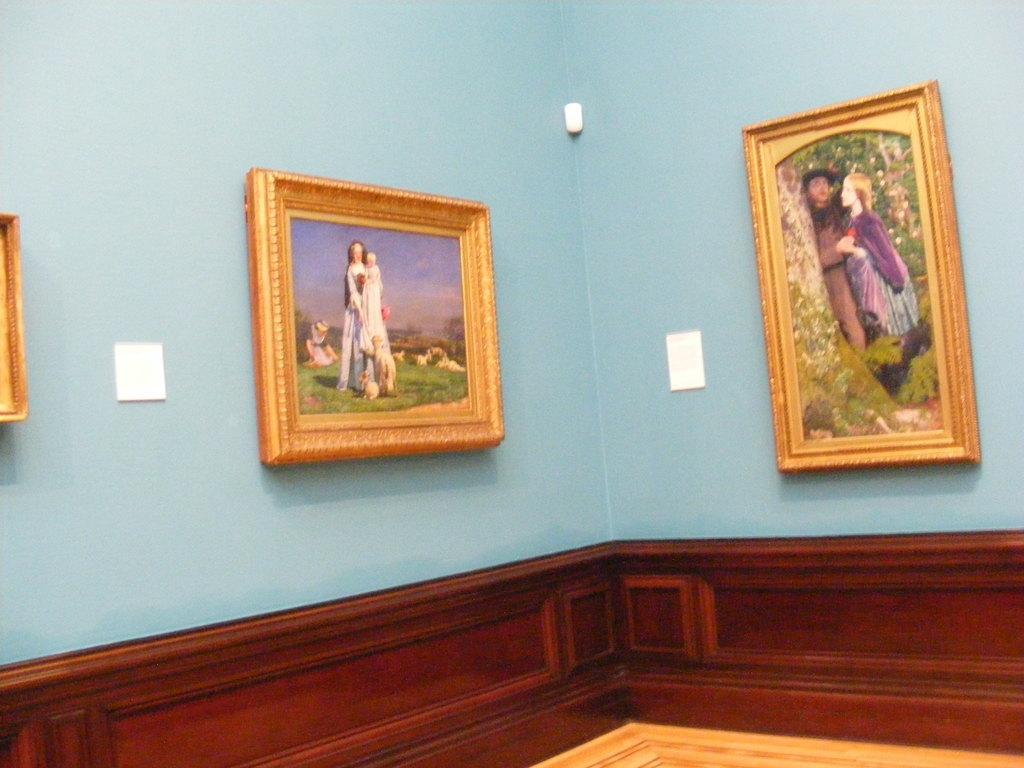Please provide a concise description of this image. This picture describes about inside view of a room, in this we can find few frames on the wall. 